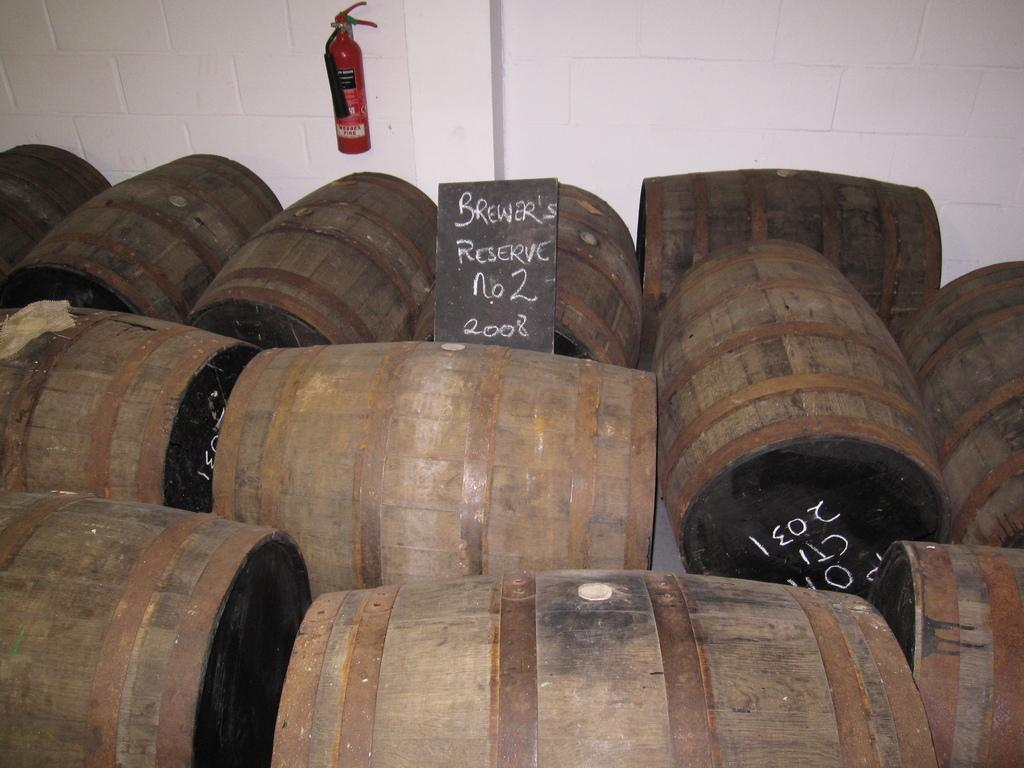What objects are on the ground in the foreground of the image? There are barrels on the ground in the foreground of the image. What is placed on top of the barrels? There is a board on the barrels. What can be seen in the background of the image? There is a white wall in the background of the image. What safety device is present on the white wall? There is a fire extinguisher on the wall in the background. Where is the frog sitting on the board in the image? There is no frog present in the image. What type of bait is used on the barrels in the image? There is no bait present in the image; it features barrels with a board on top. 